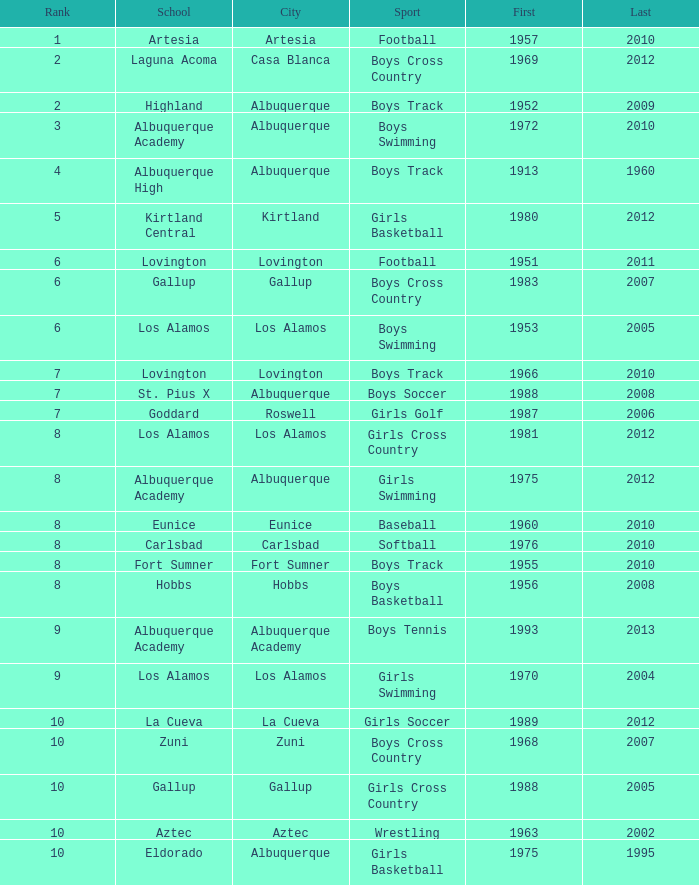What city is the school that had less than 17 titles in boys basketball with the last title being after 2005? Hobbs. I'm looking to parse the entire table for insights. Could you assist me with that? {'header': ['Rank', 'School', 'City', 'Sport', 'First', 'Last'], 'rows': [['1', 'Artesia', 'Artesia', 'Football', '1957', '2010'], ['2', 'Laguna Acoma', 'Casa Blanca', 'Boys Cross Country', '1969', '2012'], ['2', 'Highland', 'Albuquerque', 'Boys Track', '1952', '2009'], ['3', 'Albuquerque Academy', 'Albuquerque', 'Boys Swimming', '1972', '2010'], ['4', 'Albuquerque High', 'Albuquerque', 'Boys Track', '1913', '1960'], ['5', 'Kirtland Central', 'Kirtland', 'Girls Basketball', '1980', '2012'], ['6', 'Lovington', 'Lovington', 'Football', '1951', '2011'], ['6', 'Gallup', 'Gallup', 'Boys Cross Country', '1983', '2007'], ['6', 'Los Alamos', 'Los Alamos', 'Boys Swimming', '1953', '2005'], ['7', 'Lovington', 'Lovington', 'Boys Track', '1966', '2010'], ['7', 'St. Pius X', 'Albuquerque', 'Boys Soccer', '1988', '2008'], ['7', 'Goddard', 'Roswell', 'Girls Golf', '1987', '2006'], ['8', 'Los Alamos', 'Los Alamos', 'Girls Cross Country', '1981', '2012'], ['8', 'Albuquerque Academy', 'Albuquerque', 'Girls Swimming', '1975', '2012'], ['8', 'Eunice', 'Eunice', 'Baseball', '1960', '2010'], ['8', 'Carlsbad', 'Carlsbad', 'Softball', '1976', '2010'], ['8', 'Fort Sumner', 'Fort Sumner', 'Boys Track', '1955', '2010'], ['8', 'Hobbs', 'Hobbs', 'Boys Basketball', '1956', '2008'], ['9', 'Albuquerque Academy', 'Albuquerque Academy', 'Boys Tennis', '1993', '2013'], ['9', 'Los Alamos', 'Los Alamos', 'Girls Swimming', '1970', '2004'], ['10', 'La Cueva', 'La Cueva', 'Girls Soccer', '1989', '2012'], ['10', 'Zuni', 'Zuni', 'Boys Cross Country', '1968', '2007'], ['10', 'Gallup', 'Gallup', 'Girls Cross Country', '1988', '2005'], ['10', 'Aztec', 'Aztec', 'Wrestling', '1963', '2002'], ['10', 'Eldorado', 'Albuquerque', 'Girls Basketball', '1975', '1995']]} 